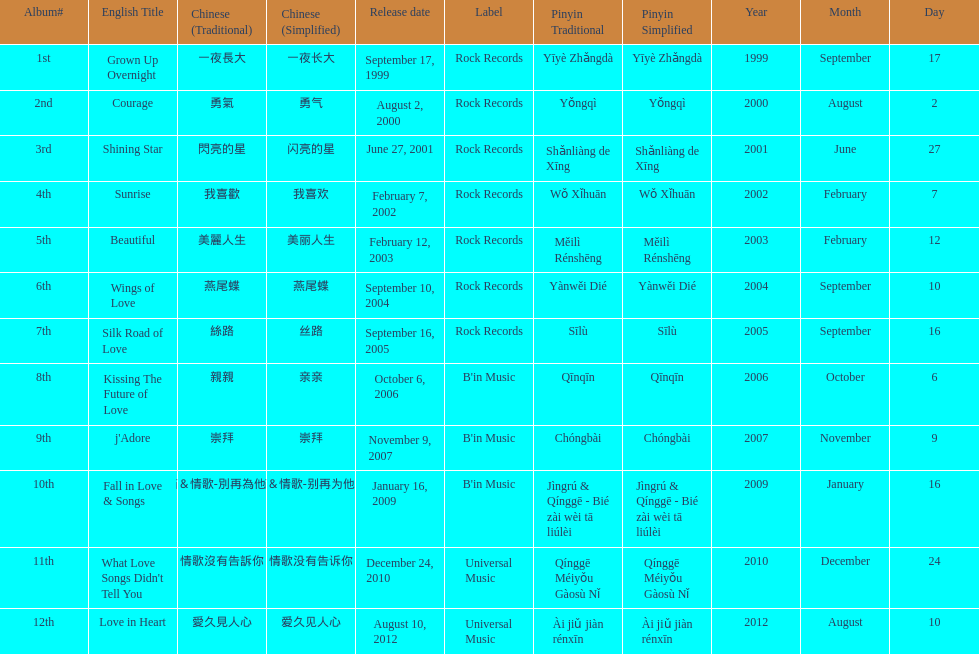Was the album beautiful released before the album love in heart? Yes. 